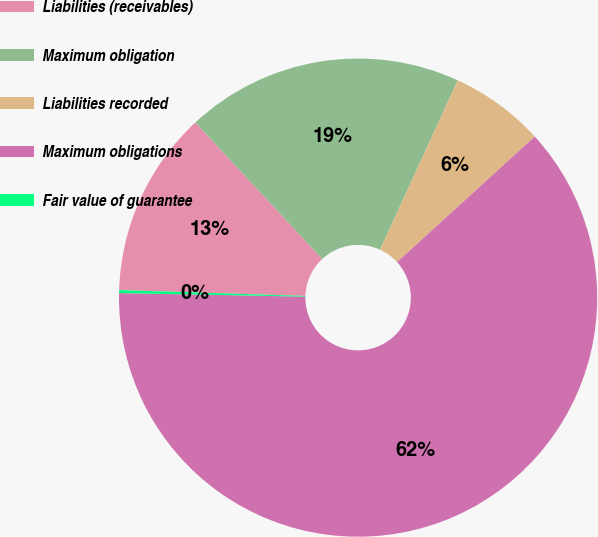Convert chart. <chart><loc_0><loc_0><loc_500><loc_500><pie_chart><fcel>Liabilities (receivables)<fcel>Maximum obligation<fcel>Liabilities recorded<fcel>Maximum obligations<fcel>Fair value of guarantee<nl><fcel>12.58%<fcel>18.76%<fcel>6.39%<fcel>62.07%<fcel>0.2%<nl></chart> 